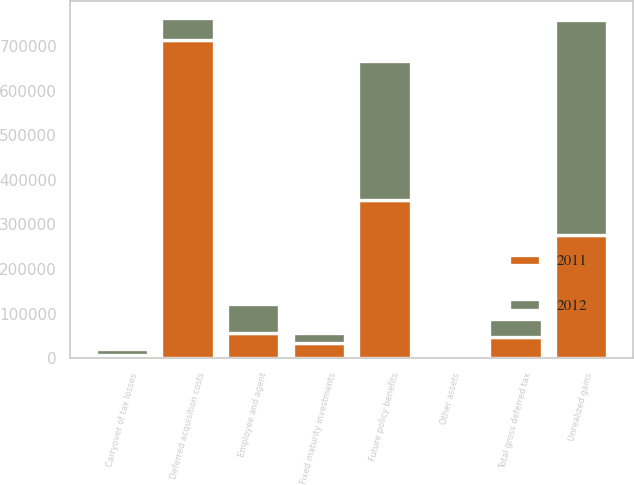Convert chart. <chart><loc_0><loc_0><loc_500><loc_500><stacked_bar_chart><ecel><fcel>Fixed maturity investments<fcel>Carryover of tax losses<fcel>Other assets<fcel>Total gross deferred tax<fcel>Unrealized gains<fcel>Employee and agent<fcel>Deferred acquisition costs<fcel>Future policy benefits<nl><fcel>2012<fcel>22387<fcel>14177<fcel>4084<fcel>40648<fcel>481804<fcel>65877<fcel>48608<fcel>311366<nl><fcel>2011<fcel>35670<fcel>7429<fcel>5509<fcel>48608<fcel>276591<fcel>57136<fcel>712974<fcel>355825<nl></chart> 